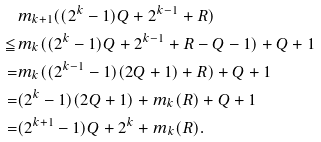Convert formula to latex. <formula><loc_0><loc_0><loc_500><loc_500>& m _ { k + 1 } ( ( 2 ^ { k } - 1 ) Q + 2 ^ { k - 1 } + R ) \\ \leqq & m _ { k } ( ( 2 ^ { k } - 1 ) Q + 2 ^ { k - 1 } + R - Q - 1 ) + Q + 1 \\ = & m _ { k } ( ( 2 ^ { k - 1 } - 1 ) ( 2 Q + 1 ) + R ) + Q + 1 \\ = & ( 2 ^ { k } - 1 ) ( 2 Q + 1 ) + m _ { k } ( R ) + Q + 1 \\ = & ( 2 ^ { k + 1 } - 1 ) Q + 2 ^ { k } + m _ { k } ( R ) .</formula> 